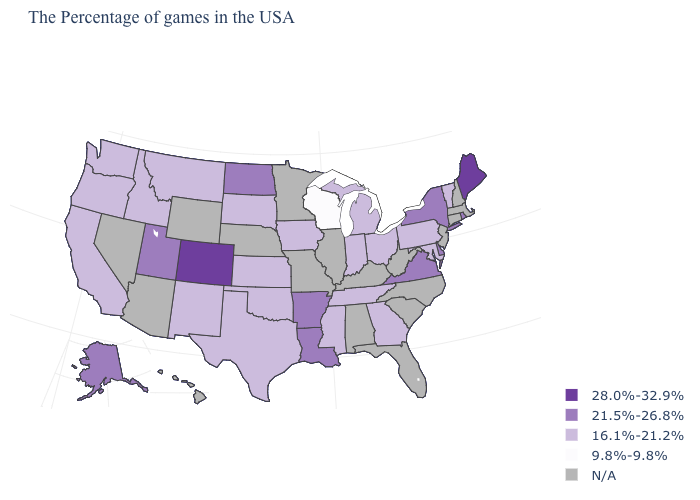How many symbols are there in the legend?
Write a very short answer. 5. What is the highest value in states that border Pennsylvania?
Concise answer only. 21.5%-26.8%. What is the value of Delaware?
Keep it brief. 21.5%-26.8%. Name the states that have a value in the range 21.5%-26.8%?
Be succinct. Rhode Island, New York, Delaware, Virginia, Louisiana, Arkansas, North Dakota, Utah, Alaska. Which states have the lowest value in the MidWest?
Keep it brief. Wisconsin. Name the states that have a value in the range N/A?
Keep it brief. Massachusetts, New Hampshire, Connecticut, New Jersey, North Carolina, South Carolina, West Virginia, Florida, Kentucky, Alabama, Illinois, Missouri, Minnesota, Nebraska, Wyoming, Arizona, Nevada, Hawaii. Which states have the highest value in the USA?
Answer briefly. Maine, Colorado. Name the states that have a value in the range 28.0%-32.9%?
Quick response, please. Maine, Colorado. Name the states that have a value in the range 16.1%-21.2%?
Write a very short answer. Vermont, Maryland, Pennsylvania, Ohio, Georgia, Michigan, Indiana, Tennessee, Mississippi, Iowa, Kansas, Oklahoma, Texas, South Dakota, New Mexico, Montana, Idaho, California, Washington, Oregon. What is the value of South Dakota?
Quick response, please. 16.1%-21.2%. Name the states that have a value in the range 28.0%-32.9%?
Give a very brief answer. Maine, Colorado. Does New Mexico have the highest value in the USA?
Quick response, please. No. What is the value of Connecticut?
Concise answer only. N/A. Is the legend a continuous bar?
Concise answer only. No. 